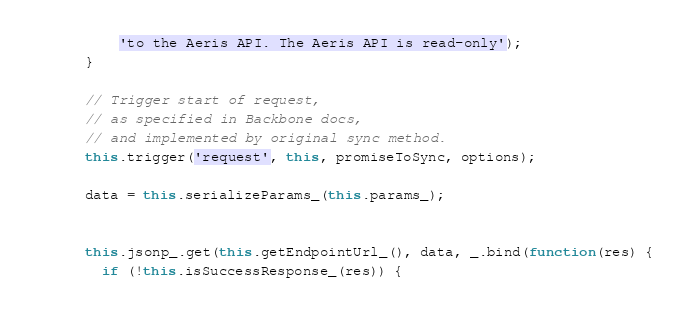<code> <loc_0><loc_0><loc_500><loc_500><_JavaScript_>          'to the Aeris API. The Aeris API is read-only');
      }

      // Trigger start of request,
      // as specified in Backbone docs,
      // and implemented by original sync method.
      this.trigger('request', this, promiseToSync, options);

      data = this.serializeParams_(this.params_);


      this.jsonp_.get(this.getEndpointUrl_(), data, _.bind(function(res) {
        if (!this.isSuccessResponse_(res)) {</code> 